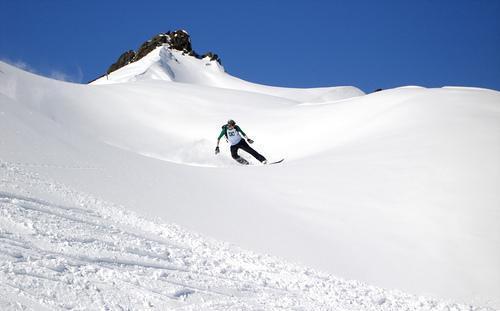How many people are here?
Give a very brief answer. 1. 